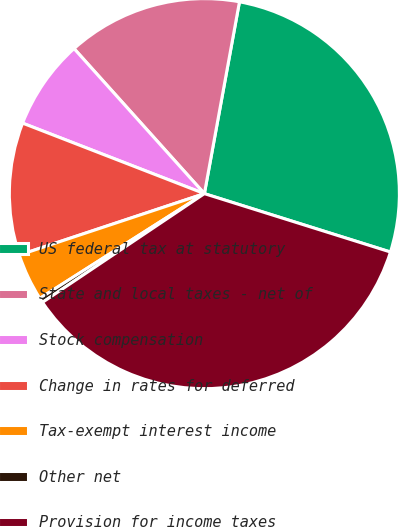Convert chart. <chart><loc_0><loc_0><loc_500><loc_500><pie_chart><fcel>US federal tax at statutory<fcel>State and local taxes - net of<fcel>Stock compensation<fcel>Change in rates for deferred<fcel>Tax-exempt interest income<fcel>Other net<fcel>Provision for income taxes<nl><fcel>26.96%<fcel>14.53%<fcel>7.46%<fcel>10.99%<fcel>3.92%<fcel>0.39%<fcel>35.75%<nl></chart> 